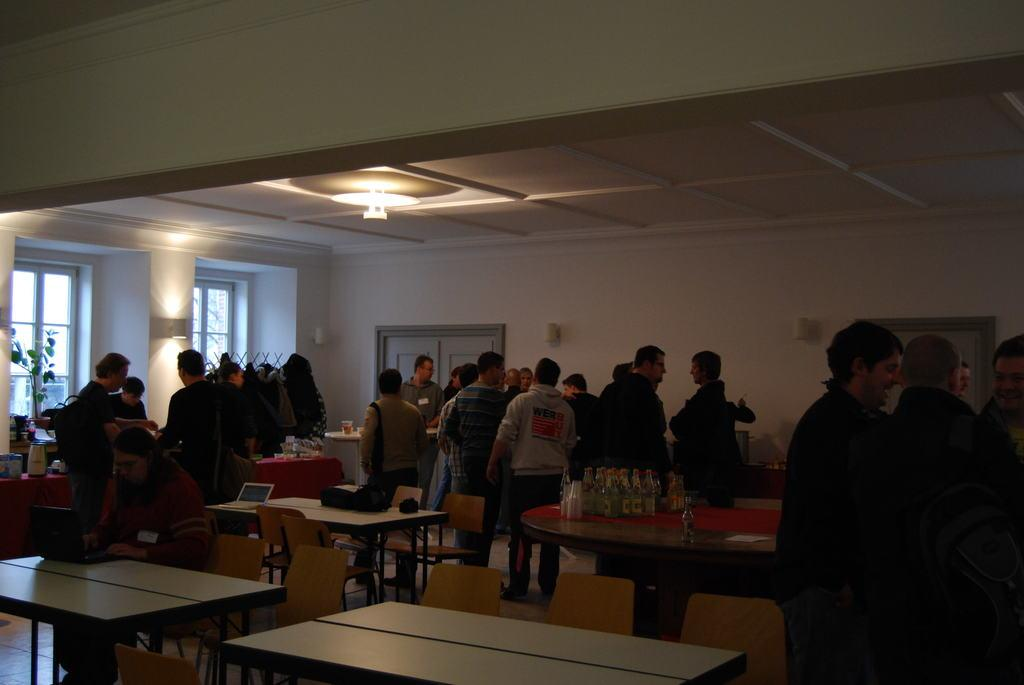What is the setting of the image? People are gathered in a hall. What furniture is present in the hall? There are tables and chairs in the hall. What can be seen in the background of the image? There are windows and a door in the background. What provides illumination in the hall? There are lights in the hall. What reason does the shirt have for being in the image? There is no shirt present in the image; it is a gathering of people in a hall with tables, chairs, lights, windows, and a door. What type of beast can be seen interacting with the people in the image? There is no beast present in the image; it is a gathering of people in a hall with tables, chairs, lights, windows, and a door. 